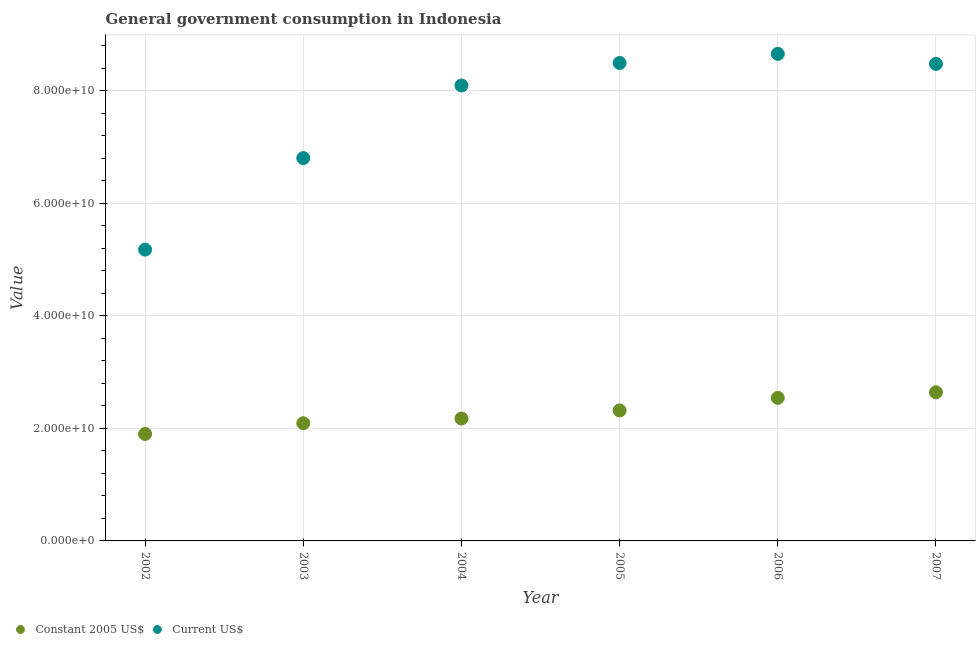How many different coloured dotlines are there?
Offer a terse response. 2. Is the number of dotlines equal to the number of legend labels?
Offer a very short reply. Yes. What is the value consumed in constant 2005 us$ in 2003?
Ensure brevity in your answer.  2.09e+1. Across all years, what is the maximum value consumed in current us$?
Ensure brevity in your answer.  8.65e+1. Across all years, what is the minimum value consumed in current us$?
Keep it short and to the point. 5.17e+1. In which year was the value consumed in constant 2005 us$ minimum?
Your response must be concise. 2002. What is the total value consumed in constant 2005 us$ in the graph?
Offer a terse response. 1.37e+11. What is the difference between the value consumed in current us$ in 2005 and that in 2006?
Give a very brief answer. -1.62e+09. What is the difference between the value consumed in constant 2005 us$ in 2003 and the value consumed in current us$ in 2004?
Your response must be concise. -6.00e+1. What is the average value consumed in current us$ per year?
Your answer should be very brief. 7.61e+1. In the year 2002, what is the difference between the value consumed in constant 2005 us$ and value consumed in current us$?
Offer a very short reply. -3.27e+1. In how many years, is the value consumed in current us$ greater than 48000000000?
Make the answer very short. 6. What is the ratio of the value consumed in current us$ in 2004 to that in 2007?
Provide a succinct answer. 0.95. Is the value consumed in current us$ in 2003 less than that in 2006?
Your answer should be very brief. Yes. Is the difference between the value consumed in constant 2005 us$ in 2003 and 2005 greater than the difference between the value consumed in current us$ in 2003 and 2005?
Provide a succinct answer. Yes. What is the difference between the highest and the second highest value consumed in constant 2005 us$?
Your answer should be very brief. 9.89e+08. What is the difference between the highest and the lowest value consumed in constant 2005 us$?
Provide a short and direct response. 7.40e+09. Is the sum of the value consumed in constant 2005 us$ in 2003 and 2006 greater than the maximum value consumed in current us$ across all years?
Provide a succinct answer. No. Does the value consumed in current us$ monotonically increase over the years?
Your answer should be compact. No. Is the value consumed in constant 2005 us$ strictly less than the value consumed in current us$ over the years?
Provide a short and direct response. Yes. How many dotlines are there?
Offer a very short reply. 2. Does the graph contain any zero values?
Make the answer very short. No. Does the graph contain grids?
Your answer should be compact. Yes. Where does the legend appear in the graph?
Make the answer very short. Bottom left. How many legend labels are there?
Offer a terse response. 2. What is the title of the graph?
Provide a succinct answer. General government consumption in Indonesia. Does "Diarrhea" appear as one of the legend labels in the graph?
Offer a very short reply. No. What is the label or title of the X-axis?
Provide a short and direct response. Year. What is the label or title of the Y-axis?
Provide a succinct answer. Value. What is the Value in Constant 2005 US$ in 2002?
Provide a succinct answer. 1.90e+1. What is the Value in Current US$ in 2002?
Your response must be concise. 5.17e+1. What is the Value of Constant 2005 US$ in 2003?
Your answer should be very brief. 2.09e+1. What is the Value of Current US$ in 2003?
Your response must be concise. 6.80e+1. What is the Value in Constant 2005 US$ in 2004?
Offer a very short reply. 2.17e+1. What is the Value in Current US$ in 2004?
Your response must be concise. 8.09e+1. What is the Value of Constant 2005 US$ in 2005?
Provide a short and direct response. 2.32e+1. What is the Value in Current US$ in 2005?
Your answer should be compact. 8.49e+1. What is the Value in Constant 2005 US$ in 2006?
Provide a short and direct response. 2.54e+1. What is the Value in Current US$ in 2006?
Your answer should be very brief. 8.65e+1. What is the Value of Constant 2005 US$ in 2007?
Make the answer very short. 2.64e+1. What is the Value of Current US$ in 2007?
Keep it short and to the point. 8.47e+1. Across all years, what is the maximum Value in Constant 2005 US$?
Make the answer very short. 2.64e+1. Across all years, what is the maximum Value of Current US$?
Provide a succinct answer. 8.65e+1. Across all years, what is the minimum Value in Constant 2005 US$?
Your answer should be compact. 1.90e+1. Across all years, what is the minimum Value of Current US$?
Keep it short and to the point. 5.17e+1. What is the total Value in Constant 2005 US$ in the graph?
Your answer should be very brief. 1.37e+11. What is the total Value of Current US$ in the graph?
Provide a succinct answer. 4.57e+11. What is the difference between the Value of Constant 2005 US$ in 2002 and that in 2003?
Ensure brevity in your answer.  -1.91e+09. What is the difference between the Value in Current US$ in 2002 and that in 2003?
Make the answer very short. -1.63e+1. What is the difference between the Value in Constant 2005 US$ in 2002 and that in 2004?
Your answer should be very brief. -2.74e+09. What is the difference between the Value of Current US$ in 2002 and that in 2004?
Your response must be concise. -2.91e+1. What is the difference between the Value of Constant 2005 US$ in 2002 and that in 2005?
Make the answer very short. -4.18e+09. What is the difference between the Value in Current US$ in 2002 and that in 2005?
Offer a terse response. -3.32e+1. What is the difference between the Value of Constant 2005 US$ in 2002 and that in 2006?
Provide a short and direct response. -6.41e+09. What is the difference between the Value in Current US$ in 2002 and that in 2006?
Your response must be concise. -3.48e+1. What is the difference between the Value in Constant 2005 US$ in 2002 and that in 2007?
Give a very brief answer. -7.40e+09. What is the difference between the Value in Current US$ in 2002 and that in 2007?
Your answer should be compact. -3.30e+1. What is the difference between the Value in Constant 2005 US$ in 2003 and that in 2004?
Your response must be concise. -8.34e+08. What is the difference between the Value of Current US$ in 2003 and that in 2004?
Provide a short and direct response. -1.29e+1. What is the difference between the Value of Constant 2005 US$ in 2003 and that in 2005?
Offer a terse response. -2.28e+09. What is the difference between the Value of Current US$ in 2003 and that in 2005?
Make the answer very short. -1.69e+1. What is the difference between the Value of Constant 2005 US$ in 2003 and that in 2006?
Offer a terse response. -4.50e+09. What is the difference between the Value of Current US$ in 2003 and that in 2006?
Offer a terse response. -1.85e+1. What is the difference between the Value of Constant 2005 US$ in 2003 and that in 2007?
Make the answer very short. -5.49e+09. What is the difference between the Value in Current US$ in 2003 and that in 2007?
Ensure brevity in your answer.  -1.67e+1. What is the difference between the Value of Constant 2005 US$ in 2004 and that in 2005?
Provide a succinct answer. -1.44e+09. What is the difference between the Value of Current US$ in 2004 and that in 2005?
Make the answer very short. -4.00e+09. What is the difference between the Value in Constant 2005 US$ in 2004 and that in 2006?
Ensure brevity in your answer.  -3.67e+09. What is the difference between the Value in Current US$ in 2004 and that in 2006?
Your answer should be very brief. -5.62e+09. What is the difference between the Value of Constant 2005 US$ in 2004 and that in 2007?
Give a very brief answer. -4.66e+09. What is the difference between the Value of Current US$ in 2004 and that in 2007?
Provide a succinct answer. -3.84e+09. What is the difference between the Value in Constant 2005 US$ in 2005 and that in 2006?
Provide a succinct answer. -2.23e+09. What is the difference between the Value in Current US$ in 2005 and that in 2006?
Make the answer very short. -1.62e+09. What is the difference between the Value of Constant 2005 US$ in 2005 and that in 2007?
Make the answer very short. -3.22e+09. What is the difference between the Value in Current US$ in 2005 and that in 2007?
Your response must be concise. 1.57e+08. What is the difference between the Value in Constant 2005 US$ in 2006 and that in 2007?
Your answer should be compact. -9.89e+08. What is the difference between the Value in Current US$ in 2006 and that in 2007?
Offer a terse response. 1.77e+09. What is the difference between the Value of Constant 2005 US$ in 2002 and the Value of Current US$ in 2003?
Your answer should be very brief. -4.90e+1. What is the difference between the Value of Constant 2005 US$ in 2002 and the Value of Current US$ in 2004?
Provide a short and direct response. -6.19e+1. What is the difference between the Value in Constant 2005 US$ in 2002 and the Value in Current US$ in 2005?
Your answer should be compact. -6.59e+1. What is the difference between the Value in Constant 2005 US$ in 2002 and the Value in Current US$ in 2006?
Offer a very short reply. -6.75e+1. What is the difference between the Value of Constant 2005 US$ in 2002 and the Value of Current US$ in 2007?
Provide a succinct answer. -6.57e+1. What is the difference between the Value of Constant 2005 US$ in 2003 and the Value of Current US$ in 2004?
Provide a succinct answer. -6.00e+1. What is the difference between the Value in Constant 2005 US$ in 2003 and the Value in Current US$ in 2005?
Make the answer very short. -6.40e+1. What is the difference between the Value in Constant 2005 US$ in 2003 and the Value in Current US$ in 2006?
Offer a very short reply. -6.56e+1. What is the difference between the Value of Constant 2005 US$ in 2003 and the Value of Current US$ in 2007?
Make the answer very short. -6.38e+1. What is the difference between the Value in Constant 2005 US$ in 2004 and the Value in Current US$ in 2005?
Give a very brief answer. -6.32e+1. What is the difference between the Value of Constant 2005 US$ in 2004 and the Value of Current US$ in 2006?
Give a very brief answer. -6.48e+1. What is the difference between the Value in Constant 2005 US$ in 2004 and the Value in Current US$ in 2007?
Give a very brief answer. -6.30e+1. What is the difference between the Value of Constant 2005 US$ in 2005 and the Value of Current US$ in 2006?
Offer a very short reply. -6.33e+1. What is the difference between the Value in Constant 2005 US$ in 2005 and the Value in Current US$ in 2007?
Provide a succinct answer. -6.16e+1. What is the difference between the Value in Constant 2005 US$ in 2006 and the Value in Current US$ in 2007?
Your answer should be very brief. -5.93e+1. What is the average Value of Constant 2005 US$ per year?
Offer a very short reply. 2.28e+1. What is the average Value of Current US$ per year?
Ensure brevity in your answer.  7.61e+1. In the year 2002, what is the difference between the Value of Constant 2005 US$ and Value of Current US$?
Your answer should be compact. -3.27e+1. In the year 2003, what is the difference between the Value of Constant 2005 US$ and Value of Current US$?
Make the answer very short. -4.71e+1. In the year 2004, what is the difference between the Value in Constant 2005 US$ and Value in Current US$?
Your answer should be compact. -5.92e+1. In the year 2005, what is the difference between the Value of Constant 2005 US$ and Value of Current US$?
Provide a short and direct response. -6.17e+1. In the year 2006, what is the difference between the Value in Constant 2005 US$ and Value in Current US$?
Ensure brevity in your answer.  -6.11e+1. In the year 2007, what is the difference between the Value of Constant 2005 US$ and Value of Current US$?
Ensure brevity in your answer.  -5.83e+1. What is the ratio of the Value in Constant 2005 US$ in 2002 to that in 2003?
Provide a succinct answer. 0.91. What is the ratio of the Value in Current US$ in 2002 to that in 2003?
Provide a short and direct response. 0.76. What is the ratio of the Value in Constant 2005 US$ in 2002 to that in 2004?
Your answer should be compact. 0.87. What is the ratio of the Value of Current US$ in 2002 to that in 2004?
Give a very brief answer. 0.64. What is the ratio of the Value in Constant 2005 US$ in 2002 to that in 2005?
Offer a very short reply. 0.82. What is the ratio of the Value of Current US$ in 2002 to that in 2005?
Give a very brief answer. 0.61. What is the ratio of the Value in Constant 2005 US$ in 2002 to that in 2006?
Keep it short and to the point. 0.75. What is the ratio of the Value of Current US$ in 2002 to that in 2006?
Offer a very short reply. 0.6. What is the ratio of the Value of Constant 2005 US$ in 2002 to that in 2007?
Offer a terse response. 0.72. What is the ratio of the Value in Current US$ in 2002 to that in 2007?
Your answer should be very brief. 0.61. What is the ratio of the Value in Constant 2005 US$ in 2003 to that in 2004?
Your answer should be very brief. 0.96. What is the ratio of the Value of Current US$ in 2003 to that in 2004?
Ensure brevity in your answer.  0.84. What is the ratio of the Value in Constant 2005 US$ in 2003 to that in 2005?
Your response must be concise. 0.9. What is the ratio of the Value of Current US$ in 2003 to that in 2005?
Offer a terse response. 0.8. What is the ratio of the Value of Constant 2005 US$ in 2003 to that in 2006?
Provide a succinct answer. 0.82. What is the ratio of the Value in Current US$ in 2003 to that in 2006?
Offer a very short reply. 0.79. What is the ratio of the Value in Constant 2005 US$ in 2003 to that in 2007?
Ensure brevity in your answer.  0.79. What is the ratio of the Value in Current US$ in 2003 to that in 2007?
Offer a very short reply. 0.8. What is the ratio of the Value in Constant 2005 US$ in 2004 to that in 2005?
Your answer should be very brief. 0.94. What is the ratio of the Value in Current US$ in 2004 to that in 2005?
Provide a short and direct response. 0.95. What is the ratio of the Value in Constant 2005 US$ in 2004 to that in 2006?
Your answer should be compact. 0.86. What is the ratio of the Value in Current US$ in 2004 to that in 2006?
Your answer should be very brief. 0.94. What is the ratio of the Value in Constant 2005 US$ in 2004 to that in 2007?
Keep it short and to the point. 0.82. What is the ratio of the Value in Current US$ in 2004 to that in 2007?
Ensure brevity in your answer.  0.95. What is the ratio of the Value of Constant 2005 US$ in 2005 to that in 2006?
Make the answer very short. 0.91. What is the ratio of the Value in Current US$ in 2005 to that in 2006?
Your answer should be compact. 0.98. What is the ratio of the Value of Constant 2005 US$ in 2005 to that in 2007?
Give a very brief answer. 0.88. What is the ratio of the Value of Current US$ in 2005 to that in 2007?
Offer a terse response. 1. What is the ratio of the Value of Constant 2005 US$ in 2006 to that in 2007?
Provide a short and direct response. 0.96. What is the ratio of the Value in Current US$ in 2006 to that in 2007?
Provide a short and direct response. 1.02. What is the difference between the highest and the second highest Value of Constant 2005 US$?
Offer a very short reply. 9.89e+08. What is the difference between the highest and the second highest Value in Current US$?
Ensure brevity in your answer.  1.62e+09. What is the difference between the highest and the lowest Value in Constant 2005 US$?
Give a very brief answer. 7.40e+09. What is the difference between the highest and the lowest Value of Current US$?
Provide a succinct answer. 3.48e+1. 